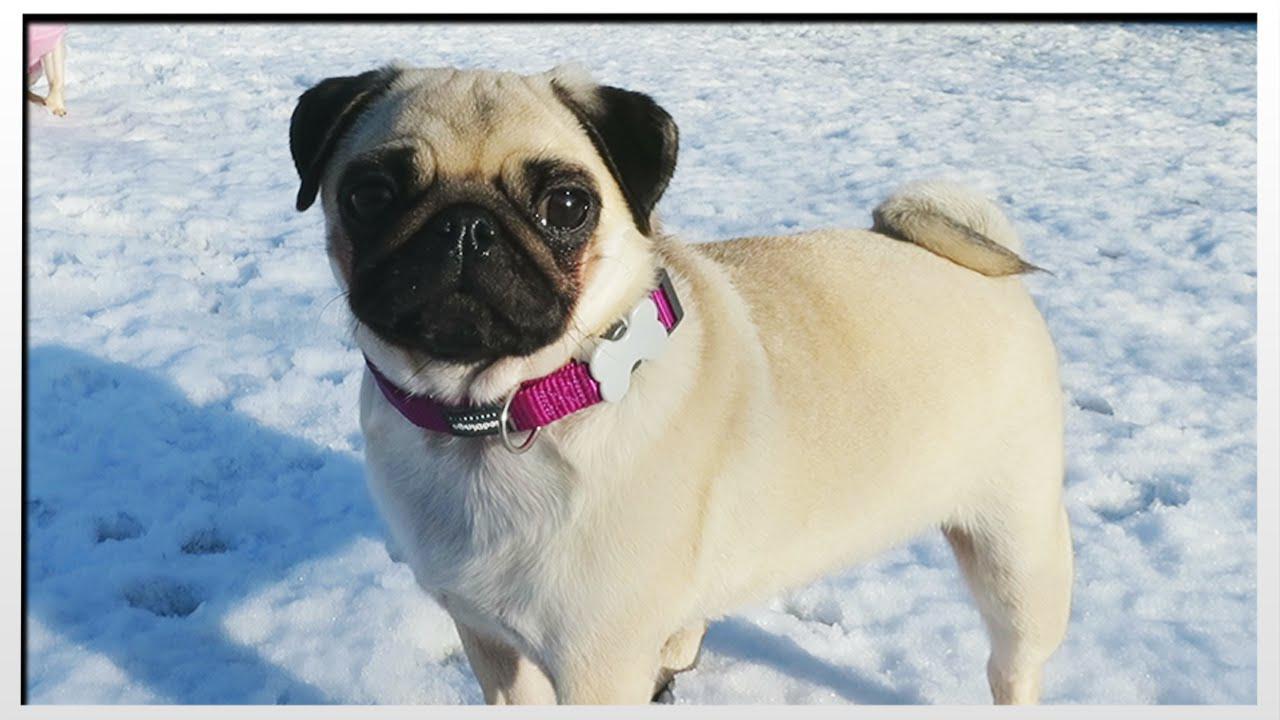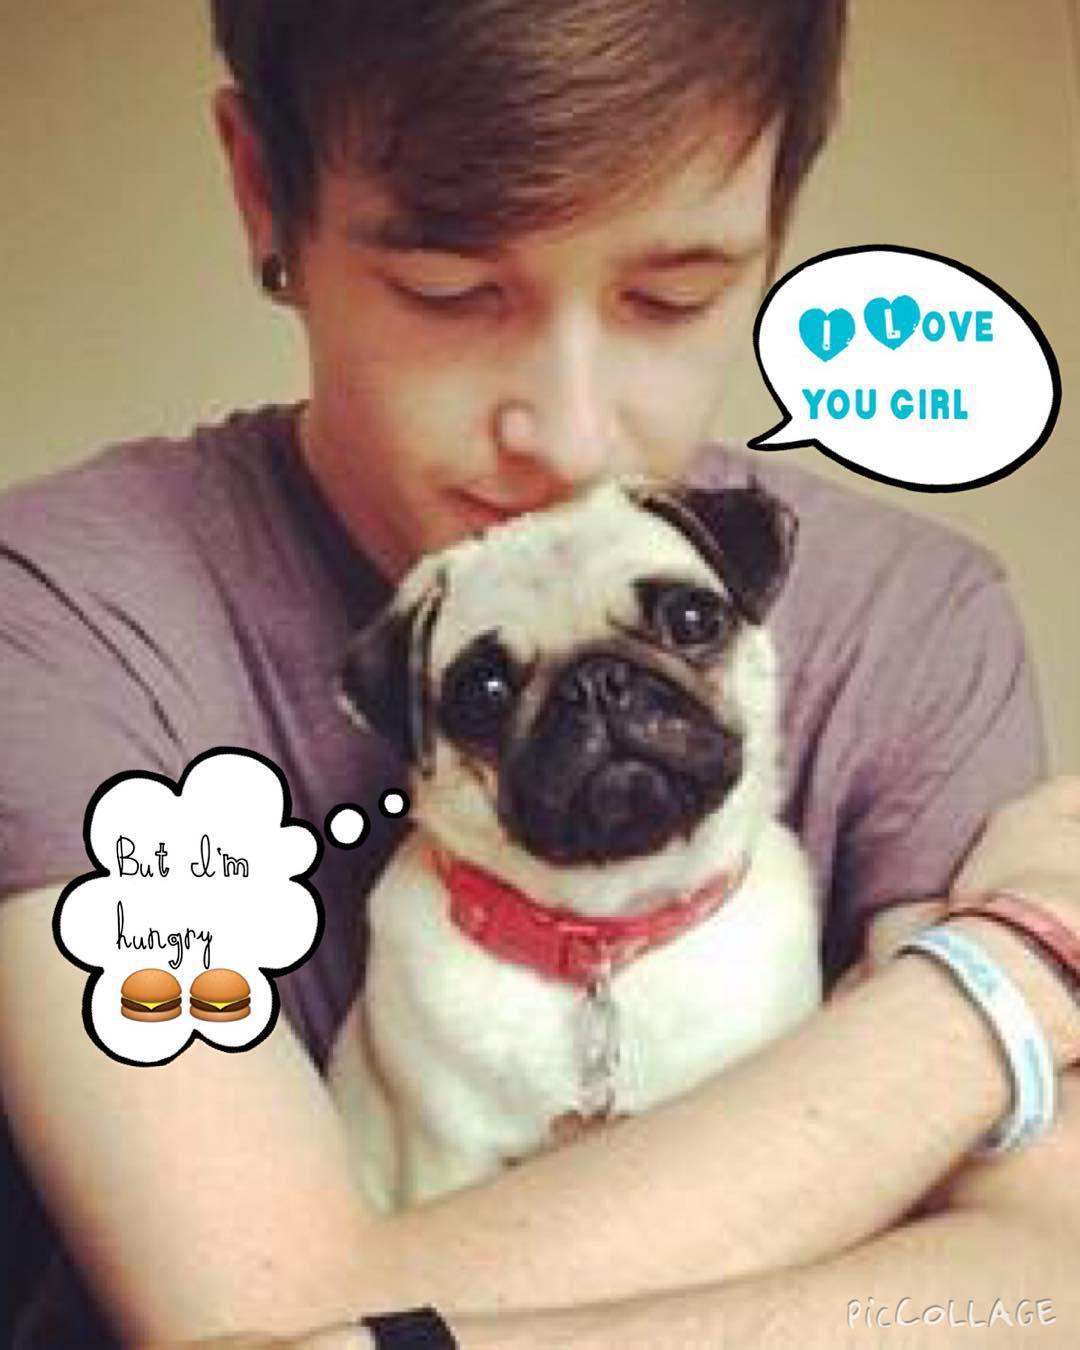The first image is the image on the left, the second image is the image on the right. For the images displayed, is the sentence "At least one image shows a human behind the dog hugging it." factually correct? Answer yes or no. Yes. The first image is the image on the left, the second image is the image on the right. Evaluate the accuracy of this statement regarding the images: "A dog is wearing something on its head.". Is it true? Answer yes or no. No. 